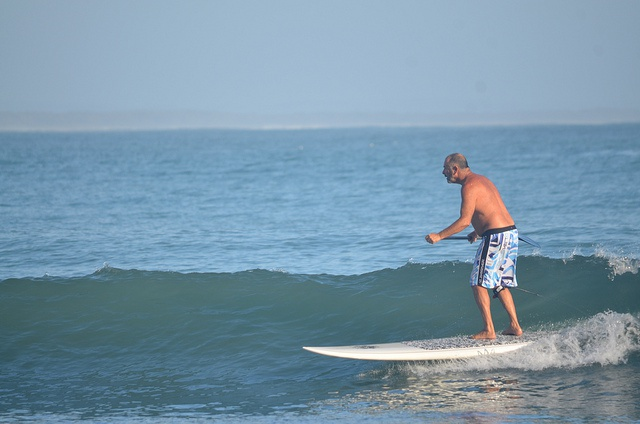Describe the objects in this image and their specific colors. I can see people in darkgray, gray, salmon, brown, and lightgray tones and surfboard in darkgray, ivory, tan, and gray tones in this image. 